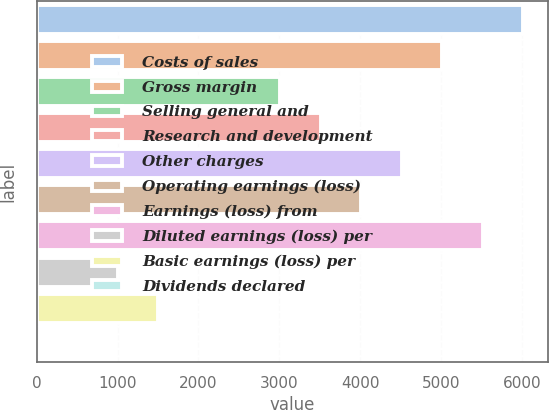Convert chart. <chart><loc_0><loc_0><loc_500><loc_500><bar_chart><fcel>Costs of sales<fcel>Gross margin<fcel>Selling general and<fcel>Research and development<fcel>Other charges<fcel>Operating earnings (loss)<fcel>Earnings (loss) from<fcel>Diluted earnings (loss) per<fcel>Basic earnings (loss) per<fcel>Dividends declared<nl><fcel>6016.8<fcel>5014<fcel>3008.43<fcel>3509.82<fcel>4512.61<fcel>4011.22<fcel>5515.4<fcel>1002.84<fcel>1504.24<fcel>0.05<nl></chart> 